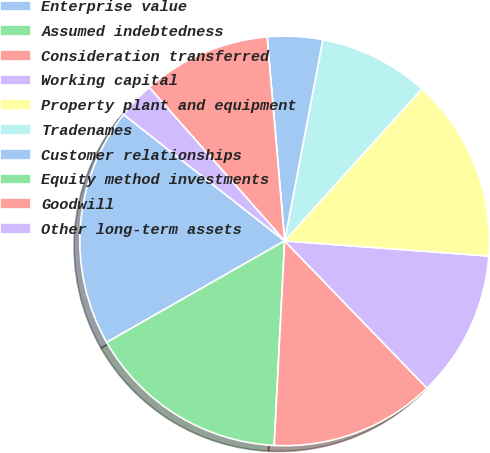Convert chart. <chart><loc_0><loc_0><loc_500><loc_500><pie_chart><fcel>Enterprise value<fcel>Assumed indebtedness<fcel>Consideration transferred<fcel>Working capital<fcel>Property plant and equipment<fcel>Tradenames<fcel>Customer relationships<fcel>Equity method investments<fcel>Goodwill<fcel>Other long-term assets<nl><fcel>18.84%<fcel>15.94%<fcel>13.04%<fcel>11.59%<fcel>14.49%<fcel>8.7%<fcel>4.35%<fcel>0.0%<fcel>10.14%<fcel>2.9%<nl></chart> 